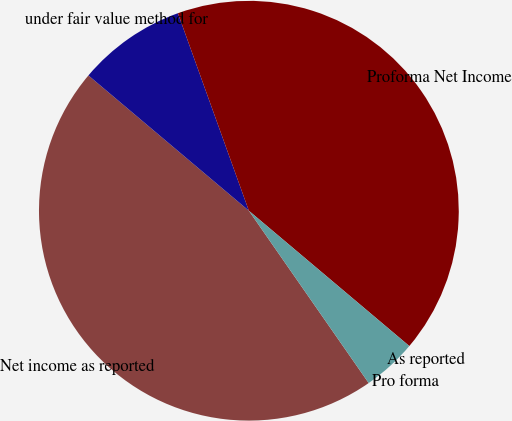<chart> <loc_0><loc_0><loc_500><loc_500><pie_chart><fcel>Net income as reported<fcel>under fair value method for<fcel>Proforma Net Income<fcel>As reported<fcel>Pro forma<nl><fcel>45.82%<fcel>8.36%<fcel>41.64%<fcel>0.0%<fcel>4.18%<nl></chart> 